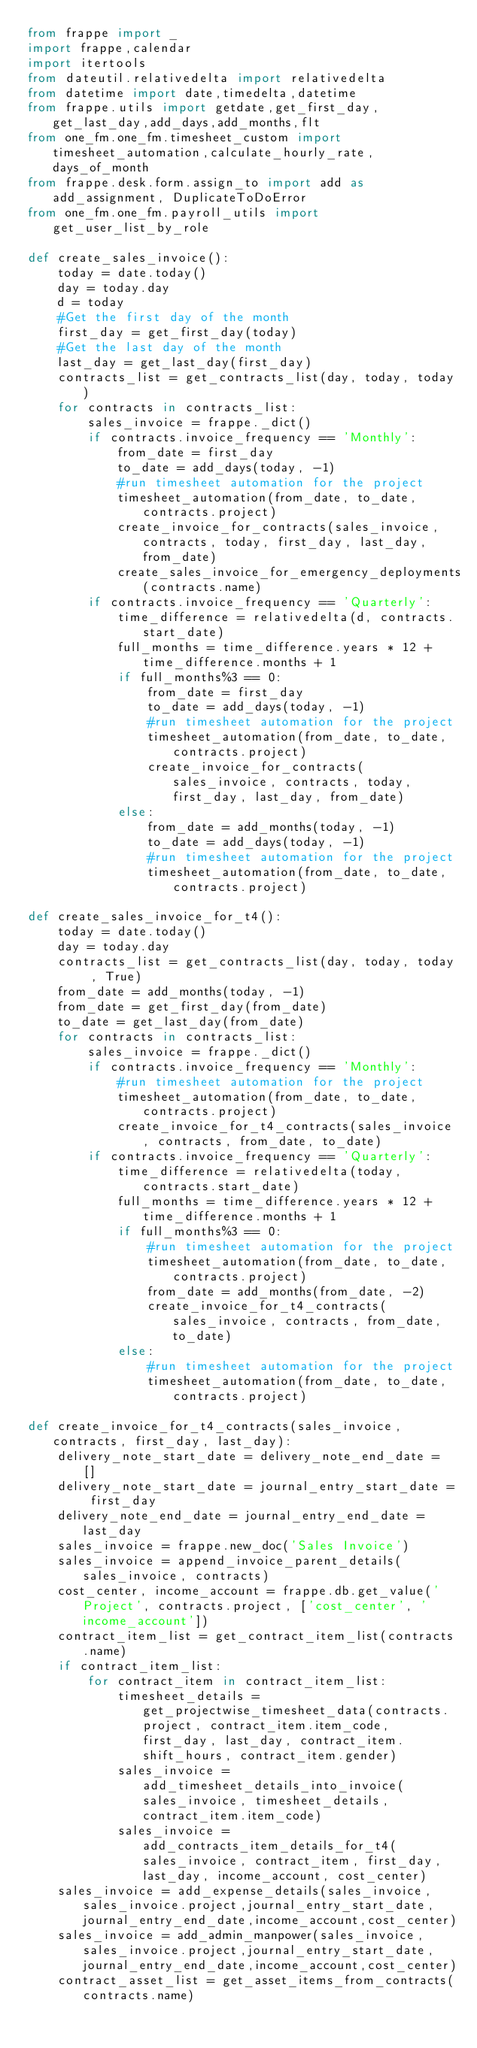Convert code to text. <code><loc_0><loc_0><loc_500><loc_500><_Python_>from frappe import _
import frappe,calendar
import itertools
from dateutil.relativedelta import relativedelta
from datetime import date,timedelta,datetime
from frappe.utils import getdate,get_first_day,get_last_day,add_days,add_months,flt
from one_fm.one_fm.timesheet_custom import timesheet_automation,calculate_hourly_rate,days_of_month
from frappe.desk.form.assign_to import add as add_assignment, DuplicateToDoError
from one_fm.one_fm.payroll_utils import get_user_list_by_role

def create_sales_invoice():
    today = date.today()
    day = today.day
    d = today
    #Get the first day of the month
    first_day = get_first_day(today)
    #Get the last day of the month
    last_day = get_last_day(first_day)
    contracts_list = get_contracts_list(day, today, today)
    for contracts in contracts_list:
        sales_invoice = frappe._dict()
        if contracts.invoice_frequency == 'Monthly':
            from_date = first_day
            to_date = add_days(today, -1)
            #run timesheet automation for the project
            timesheet_automation(from_date, to_date, contracts.project)
            create_invoice_for_contracts(sales_invoice, contracts, today, first_day, last_day, from_date)
            create_sales_invoice_for_emergency_deployments(contracts.name)
        if contracts.invoice_frequency == 'Quarterly':
            time_difference = relativedelta(d, contracts.start_date)
            full_months = time_difference.years * 12 + time_difference.months + 1
            if full_months%3 == 0:
                from_date = first_day
                to_date = add_days(today, -1)
                #run timesheet automation for the project
                timesheet_automation(from_date, to_date, contracts.project)
                create_invoice_for_contracts(sales_invoice, contracts, today, first_day, last_day, from_date)
            else:
                from_date = add_months(today, -1)
                to_date = add_days(today, -1)
                #run timesheet automation for the project
                timesheet_automation(from_date, to_date, contracts.project)

def create_sales_invoice_for_t4():
    today = date.today()
    day = today.day
    contracts_list = get_contracts_list(day, today, today , True)
    from_date = add_months(today, -1)
    from_date = get_first_day(from_date)
    to_date = get_last_day(from_date)
    for contracts in contracts_list:
        sales_invoice = frappe._dict()
        if contracts.invoice_frequency == 'Monthly':
            #run timesheet automation for the project
            timesheet_automation(from_date, to_date, contracts.project)
            create_invoice_for_t4_contracts(sales_invoice, contracts, from_date, to_date)
        if contracts.invoice_frequency == 'Quarterly':
            time_difference = relativedelta(today, contracts.start_date)
            full_months = time_difference.years * 12 + time_difference.months + 1
            if full_months%3 == 0:
                #run timesheet automation for the project
                timesheet_automation(from_date, to_date, contracts.project)
                from_date = add_months(from_date, -2)
                create_invoice_for_t4_contracts(sales_invoice, contracts, from_date, to_date)
            else:
                #run timesheet automation for the project
                timesheet_automation(from_date, to_date, contracts.project)

def create_invoice_for_t4_contracts(sales_invoice, contracts, first_day, last_day):
    delivery_note_start_date = delivery_note_end_date = []
    delivery_note_start_date = journal_entry_start_date = first_day
    delivery_note_end_date = journal_entry_end_date = last_day
    sales_invoice = frappe.new_doc('Sales Invoice')
    sales_invoice = append_invoice_parent_details(sales_invoice, contracts)
    cost_center, income_account = frappe.db.get_value('Project', contracts.project, ['cost_center', 'income_account'])
    contract_item_list = get_contract_item_list(contracts.name)
    if contract_item_list:
        for contract_item in contract_item_list:
            timesheet_details = get_projectwise_timesheet_data(contracts.project, contract_item.item_code, first_day, last_day, contract_item.shift_hours, contract_item.gender)
            sales_invoice = add_timesheet_details_into_invoice(sales_invoice, timesheet_details, contract_item.item_code)
            sales_invoice = add_contracts_item_details_for_t4(sales_invoice, contract_item, first_day, last_day, income_account, cost_center)
    sales_invoice = add_expense_details(sales_invoice,sales_invoice.project,journal_entry_start_date,journal_entry_end_date,income_account,cost_center)
    sales_invoice = add_admin_manpower(sales_invoice,sales_invoice.project,journal_entry_start_date,journal_entry_end_date,income_account,cost_center)
    contract_asset_list = get_asset_items_from_contracts(contracts.name)</code> 